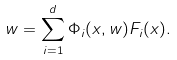<formula> <loc_0><loc_0><loc_500><loc_500>w = \sum _ { i = 1 } ^ { d } \Phi _ { i } ( x , w ) F _ { i } ( x ) .</formula> 